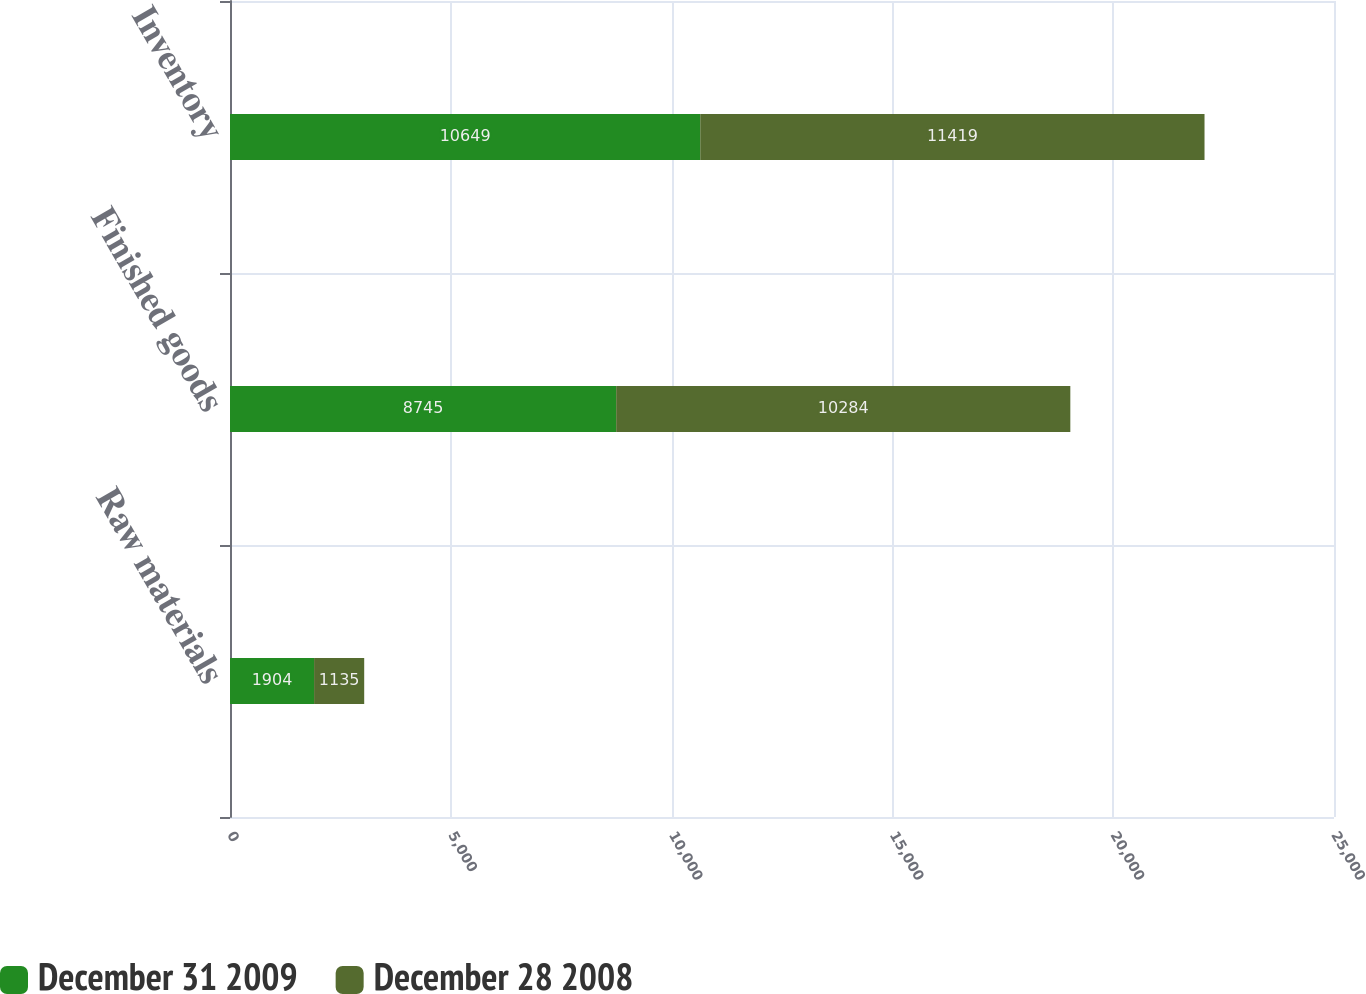<chart> <loc_0><loc_0><loc_500><loc_500><stacked_bar_chart><ecel><fcel>Raw materials<fcel>Finished goods<fcel>Inventory<nl><fcel>December 31 2009<fcel>1904<fcel>8745<fcel>10649<nl><fcel>December 28 2008<fcel>1135<fcel>10284<fcel>11419<nl></chart> 